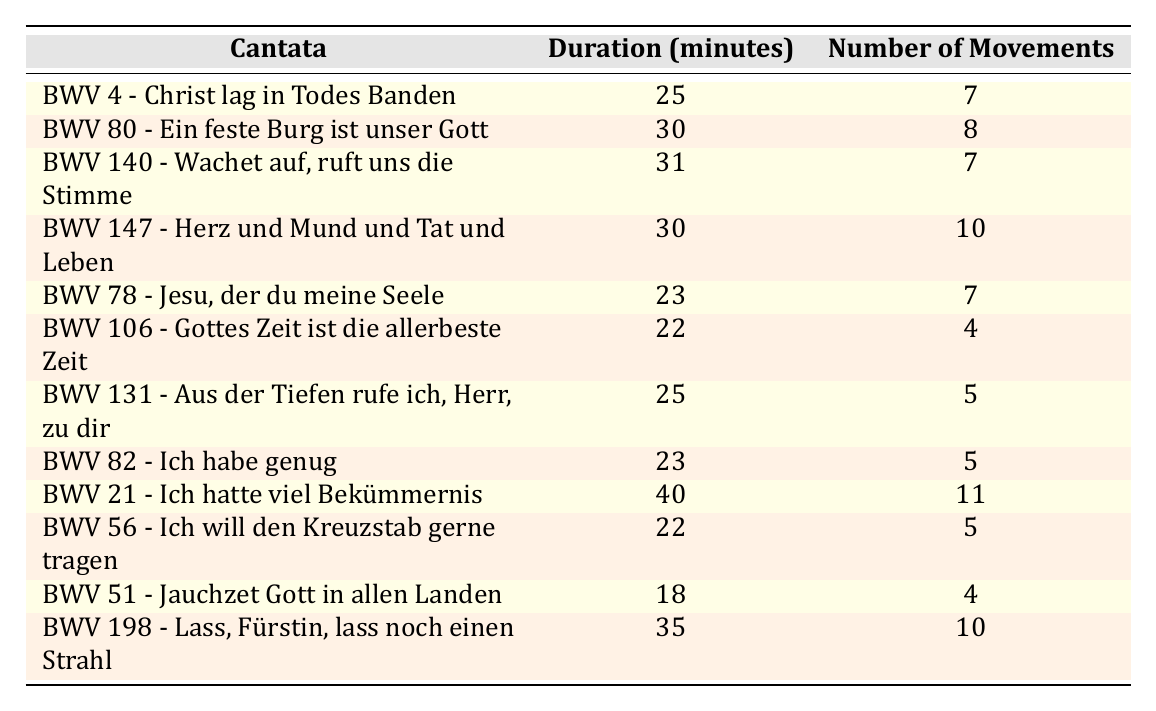What is the duration of BWV 140? The table shows that the duration of BWV 140 - Wachet auf, ruft uns die Stimme is 31 minutes.
Answer: 31 minutes How many movements are in BWV 80? According to the table, BWV 80 - Ein feste Burg ist unser Gott has 8 movements.
Answer: 8 movements Which cantata has the longest duration? Comparing the durations listed in the table, BWV 21 - Ich hatte viel Bekümmernis has the longest duration of 40 minutes.
Answer: BWV 21 - Ich hatte viel Bekümmernis Is it true that BWV 56 has more movements than BWV 51? The table shows that BWV 56 - Ich will den Kreuzstab gerne tragen has 5 movements, while BWV 51 - Jauchzet Gott in allen Landen has 4 movements. Therefore, it is true that BWV 56 has more movements.
Answer: Yes What is the average duration of the selected cantatas? First, we need to sum the durations: 25 + 30 + 31 + 30 + 23 + 22 + 25 + 23 + 40 + 22 + 18 + 35 =  309 minutes. Then we divide by the number of cantatas, which is 12, giving us an average of 309/12 = 25.75 minutes.
Answer: 25.75 minutes How many cantatas have 7 movements? Looking at the table, BWV 4, BWV 140, and BWV 78 each have 7 movements, making a total of 3 cantatas.
Answer: 3 cantatas What is the total number of movements across all cantatas? We will sum the number of movements: 7 + 8 + 7 + 10 + 7 + 4 + 5 + 5 + 11 + 5 + 4 + 10 = 78 movements total.
Answer: 78 movements Which cantatas have a duration shorter than 25 minutes? The table lists BWV 106 (22 minutes) and BWV 51 (18 minutes) as cantatas with durations shorter than 25 minutes.
Answer: BWV 106 and BWV 51 What is the difference in movements between the cantatas with the least and most movements? The cantata with the least movements is BWV 106 with 4 movements, while the one with the most is BWV 21 with 11 movements. The difference is 11 - 4 = 7 movements.
Answer: 7 movements Are there any cantatas with the same duration? The table indicates that BWV 80 and BWV 147 both have a duration of 30 minutes, confirming that there are cantatas with the same duration.
Answer: Yes 